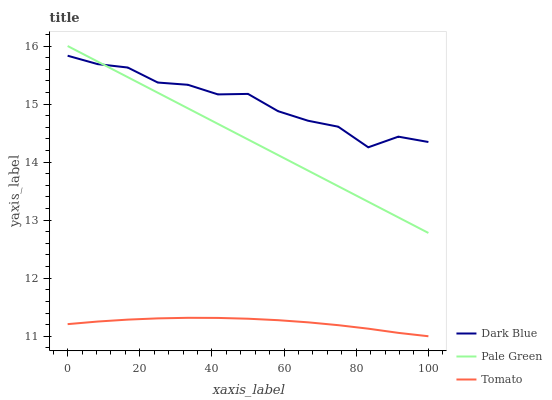Does Tomato have the minimum area under the curve?
Answer yes or no. Yes. Does Dark Blue have the maximum area under the curve?
Answer yes or no. Yes. Does Pale Green have the minimum area under the curve?
Answer yes or no. No. Does Pale Green have the maximum area under the curve?
Answer yes or no. No. Is Pale Green the smoothest?
Answer yes or no. Yes. Is Dark Blue the roughest?
Answer yes or no. Yes. Is Dark Blue the smoothest?
Answer yes or no. No. Is Pale Green the roughest?
Answer yes or no. No. Does Tomato have the lowest value?
Answer yes or no. Yes. Does Pale Green have the lowest value?
Answer yes or no. No. Does Pale Green have the highest value?
Answer yes or no. Yes. Does Dark Blue have the highest value?
Answer yes or no. No. Is Tomato less than Dark Blue?
Answer yes or no. Yes. Is Pale Green greater than Tomato?
Answer yes or no. Yes. Does Dark Blue intersect Pale Green?
Answer yes or no. Yes. Is Dark Blue less than Pale Green?
Answer yes or no. No. Is Dark Blue greater than Pale Green?
Answer yes or no. No. Does Tomato intersect Dark Blue?
Answer yes or no. No. 